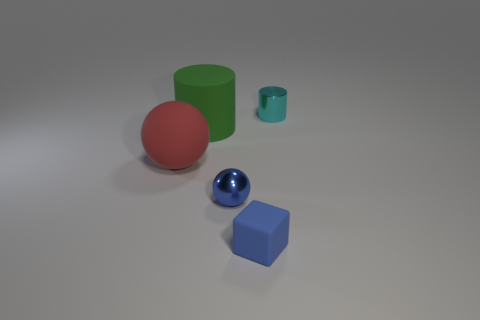Subtract all green cylinders. How many cylinders are left? 1 Subtract all cylinders. How many objects are left? 3 Subtract 1 cylinders. How many cylinders are left? 1 Add 5 small blue matte balls. How many objects exist? 10 Subtract 0 purple cubes. How many objects are left? 5 Subtract all cyan balls. Subtract all brown blocks. How many balls are left? 2 Subtract all small cylinders. Subtract all big red spheres. How many objects are left? 3 Add 2 blue balls. How many blue balls are left? 3 Add 5 red matte balls. How many red matte balls exist? 6 